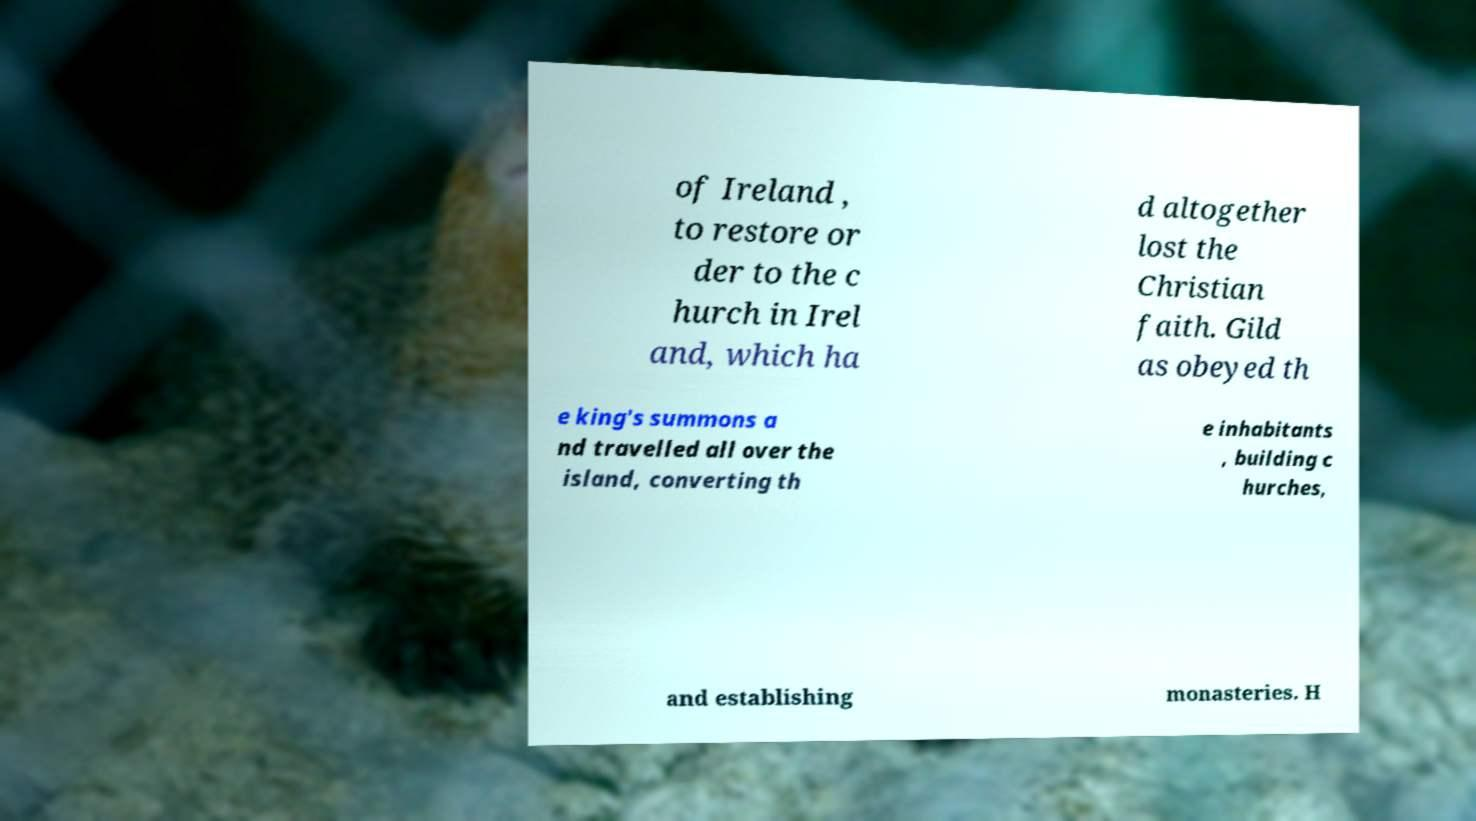Could you extract and type out the text from this image? of Ireland , to restore or der to the c hurch in Irel and, which ha d altogether lost the Christian faith. Gild as obeyed th e king's summons a nd travelled all over the island, converting th e inhabitants , building c hurches, and establishing monasteries. H 